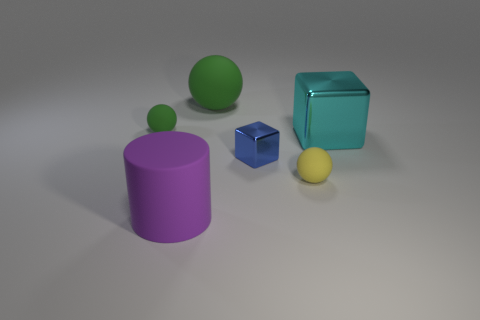There is a large green object that is the same material as the purple object; what is its shape?
Offer a terse response. Sphere. What is the color of the matte sphere that is both in front of the big green matte object and behind the yellow ball?
Keep it short and to the point. Green. How big is the metallic cube on the left side of the tiny ball right of the tiny green rubber thing?
Provide a short and direct response. Small. Are there any large blocks that have the same color as the small metallic object?
Offer a terse response. No. Are there the same number of tiny matte objects that are to the right of the big block and brown metal blocks?
Provide a succinct answer. Yes. What number of big green rubber things are there?
Your answer should be compact. 1. What shape is the thing that is both to the left of the big green ball and in front of the tiny blue metallic object?
Your response must be concise. Cylinder. There is a small matte object that is on the left side of the rubber cylinder; is it the same color as the tiny ball that is in front of the cyan cube?
Your answer should be compact. No. There is a thing that is the same color as the big rubber ball; what is its size?
Your answer should be very brief. Small. Is there a small cyan cube that has the same material as the tiny blue block?
Provide a succinct answer. No. 